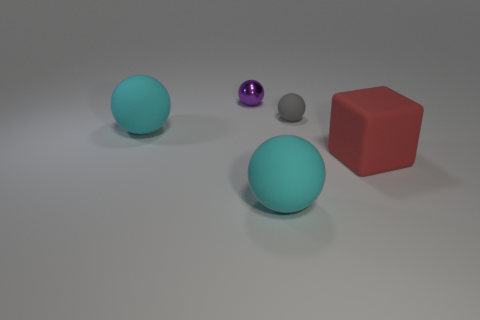Add 5 small objects. How many objects exist? 10 Subtract all tiny matte spheres. How many spheres are left? 3 Subtract all purple spheres. How many spheres are left? 3 Subtract all cubes. How many objects are left? 4 Add 1 cyan metallic objects. How many cyan metallic objects exist? 1 Subtract 0 blue blocks. How many objects are left? 5 Subtract 2 balls. How many balls are left? 2 Subtract all brown cubes. Subtract all green balls. How many cubes are left? 1 Subtract all gray balls. How many cyan blocks are left? 0 Subtract all big yellow cubes. Subtract all red objects. How many objects are left? 4 